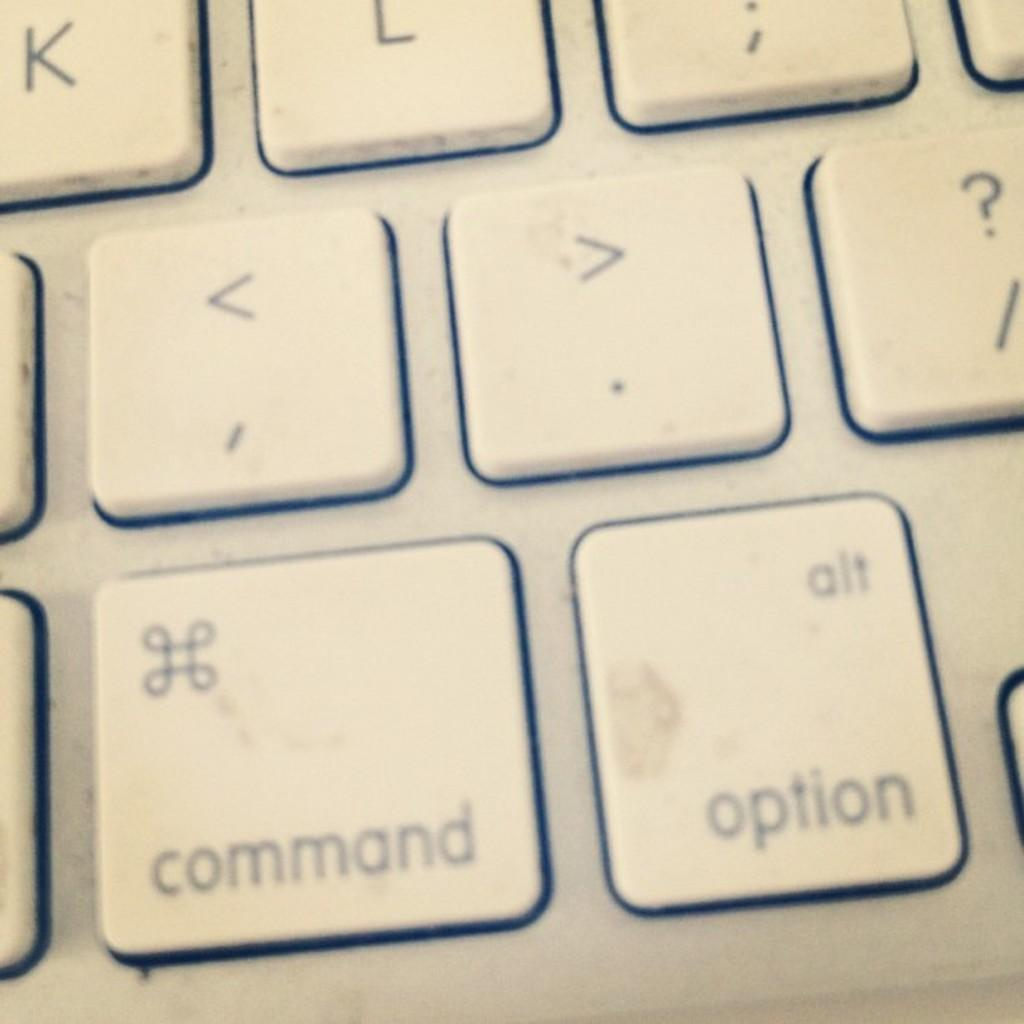What type of device is depicted in the image? There are keys of a laptop in the image. What can be found on the keys of the laptop? There are symbols and text on the keys. What type of feather is used to write the text on the keys? There is no feather present in the image, and the text on the keys is not written by hand. 